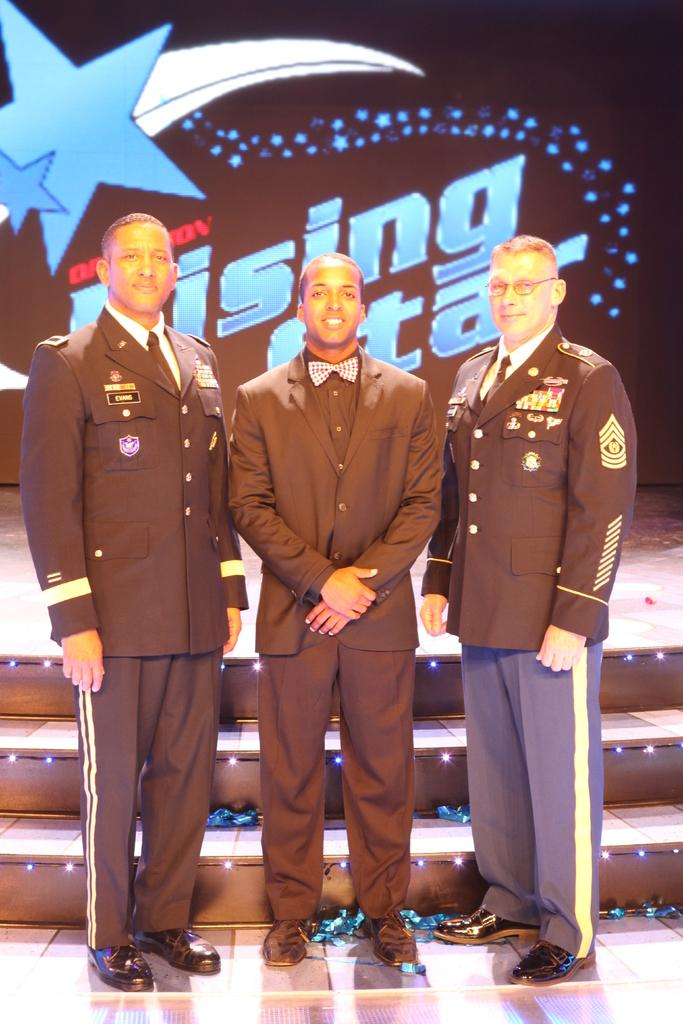Who is present in the image? There are men in the image. What are the men wearing? The men are wearing suits. What architectural feature can be seen in the image? There are stairs in the image. What type of rose can be seen in the image? There is no rose present in the image. What structure is the men's hatred directed towards in the image? There is no indication of hate or any specific structure in the image. 